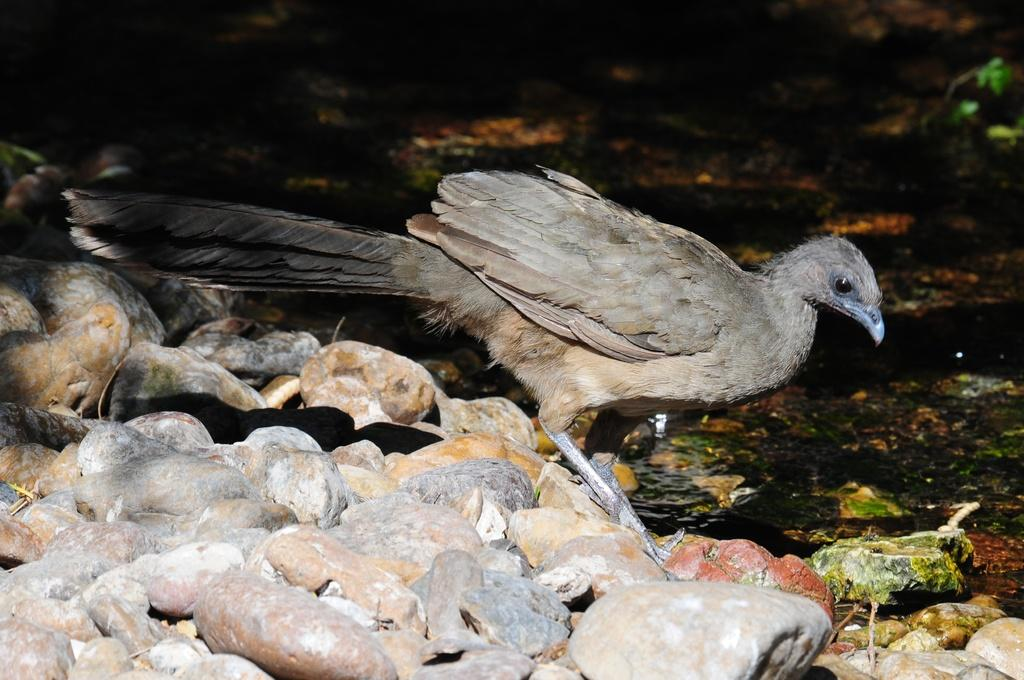What is the main subject in the center of the image? There is a bird in the center of the image. What can be seen on the left side of the image? There are stones on the left side of the image. What is visible in the background of the image? There is water visible in the background of the image. How many fingers does the bird have in the image? Birds do not have fingers; they have claws. However, the image does not show the bird's claws or any fingers. 